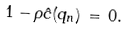Convert formula to latex. <formula><loc_0><loc_0><loc_500><loc_500>1 - \rho \hat { c } ( q _ { n } ) \, = \, 0 .</formula> 